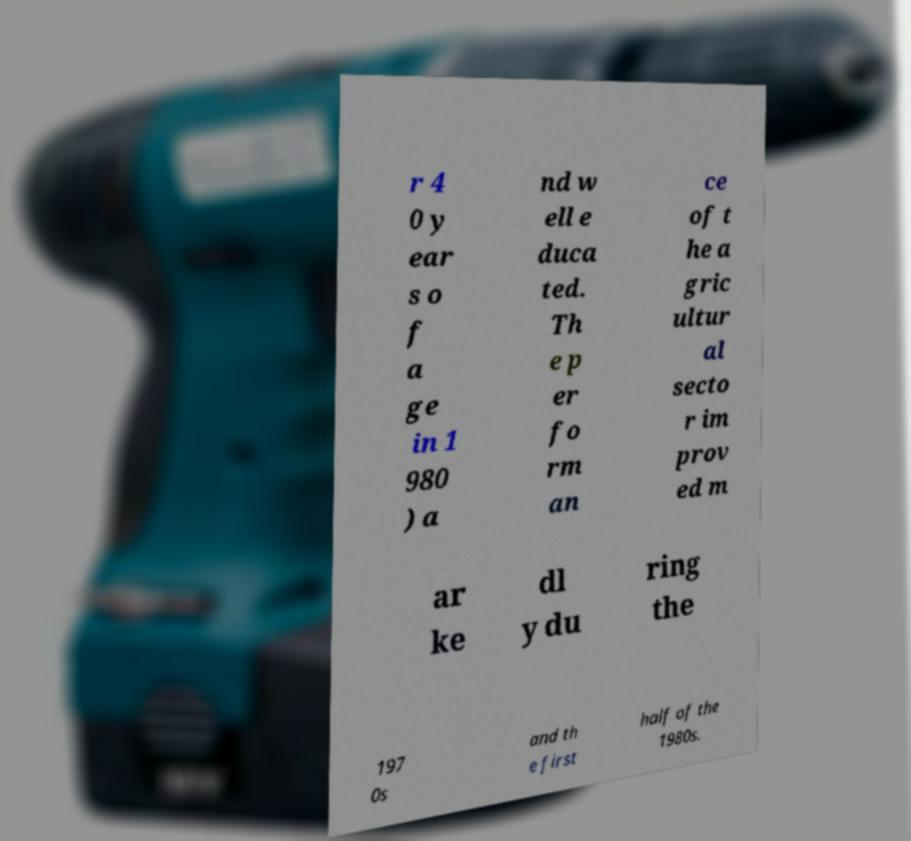Please identify and transcribe the text found in this image. r 4 0 y ear s o f a ge in 1 980 ) a nd w ell e duca ted. Th e p er fo rm an ce of t he a gric ultur al secto r im prov ed m ar ke dl y du ring the 197 0s and th e first half of the 1980s. 